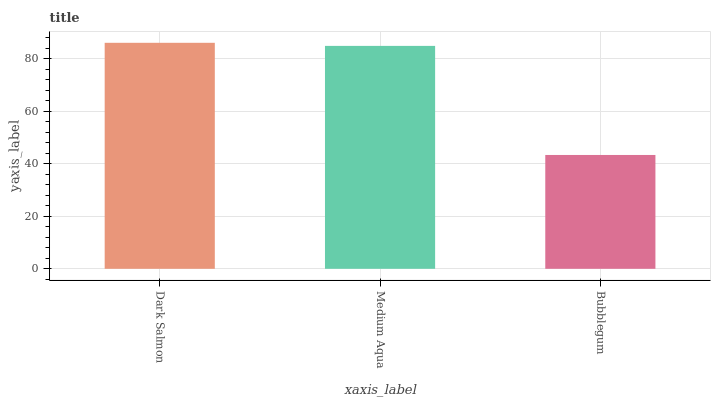Is Bubblegum the minimum?
Answer yes or no. Yes. Is Dark Salmon the maximum?
Answer yes or no. Yes. Is Medium Aqua the minimum?
Answer yes or no. No. Is Medium Aqua the maximum?
Answer yes or no. No. Is Dark Salmon greater than Medium Aqua?
Answer yes or no. Yes. Is Medium Aqua less than Dark Salmon?
Answer yes or no. Yes. Is Medium Aqua greater than Dark Salmon?
Answer yes or no. No. Is Dark Salmon less than Medium Aqua?
Answer yes or no. No. Is Medium Aqua the high median?
Answer yes or no. Yes. Is Medium Aqua the low median?
Answer yes or no. Yes. Is Bubblegum the high median?
Answer yes or no. No. Is Dark Salmon the low median?
Answer yes or no. No. 